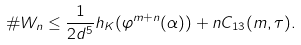<formula> <loc_0><loc_0><loc_500><loc_500>\# W _ { n } \leq \frac { 1 } { 2 d ^ { 5 } } h _ { K } ( \varphi ^ { m + n } ( \alpha ) ) + n C _ { 1 3 } ( m , \tau ) .</formula> 